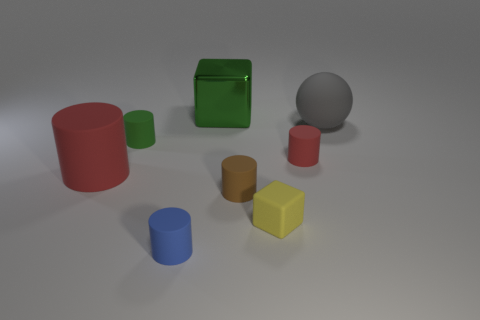Is there any other thing that has the same color as the metal object?
Your answer should be compact. Yes. Does the object that is in front of the tiny yellow cube have the same material as the small yellow object?
Your answer should be compact. Yes. Are there the same number of small blue cylinders right of the small yellow matte thing and small cylinders that are in front of the tiny brown object?
Keep it short and to the point. No. What is the size of the matte thing that is on the left side of the green thing on the left side of the big green metal thing?
Your answer should be compact. Large. There is a object that is in front of the green matte thing and left of the tiny blue cylinder; what material is it?
Your answer should be very brief. Rubber. How many other objects are the same size as the blue matte cylinder?
Keep it short and to the point. 4. The rubber sphere has what color?
Provide a succinct answer. Gray. Does the big rubber thing that is left of the matte ball have the same color as the cylinder on the right side of the brown rubber cylinder?
Your answer should be compact. Yes. What size is the gray rubber object?
Make the answer very short. Large. There is a cube that is in front of the large gray matte ball; what size is it?
Offer a very short reply. Small. 